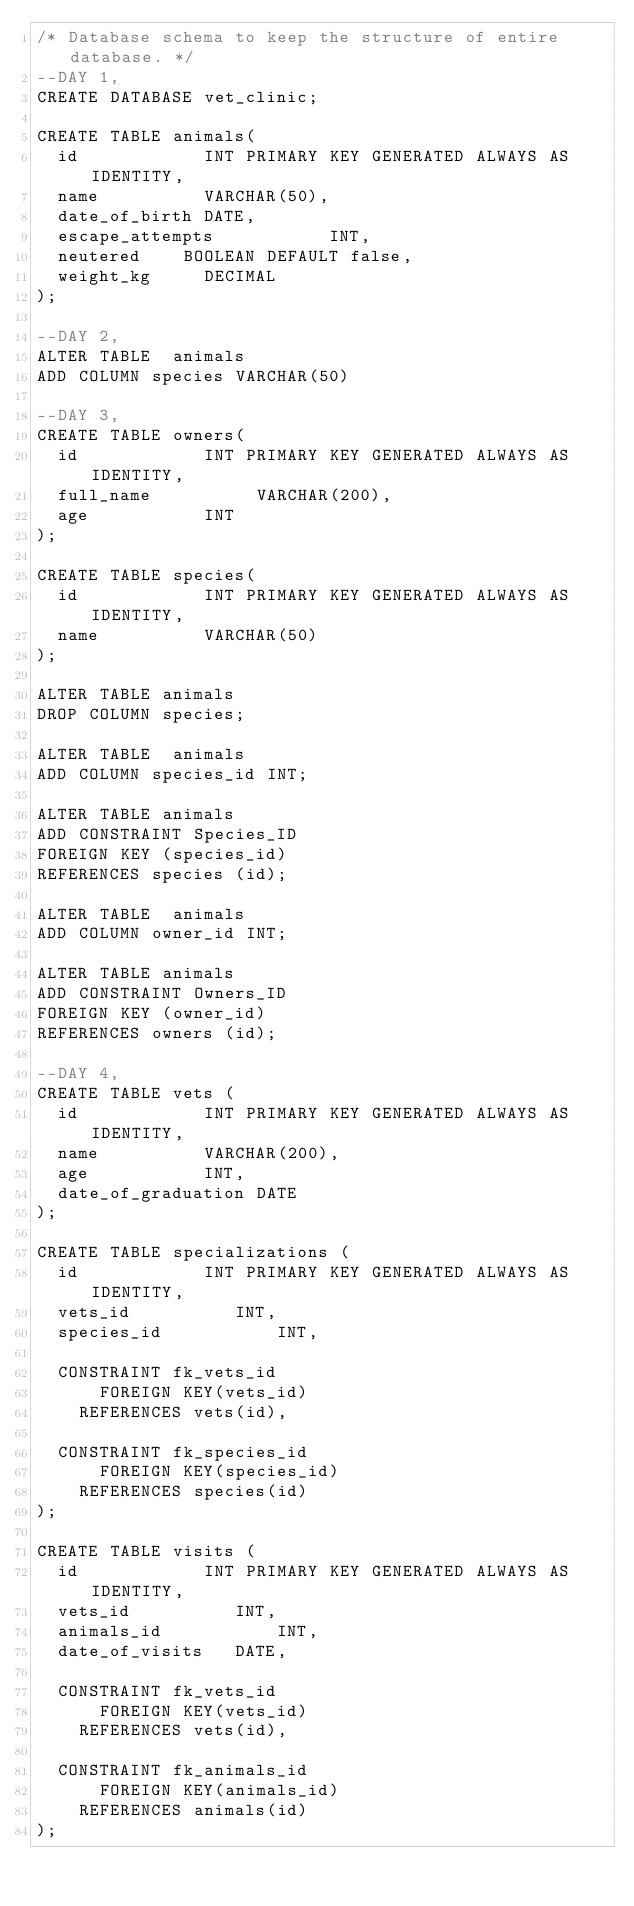<code> <loc_0><loc_0><loc_500><loc_500><_SQL_>/* Database schema to keep the structure of entire database. */
--DAY 1,
CREATE DATABASE vet_clinic;

CREATE TABLE animals(
  id            INT PRIMARY KEY GENERATED ALWAYS AS IDENTITY,
  name          VARCHAR(50),
  date_of_birth DATE,
  escape_attempts           INT,
  neutered    BOOLEAN DEFAULT false,
  weight_kg     DECIMAL
);

--DAY 2,
ALTER TABLE  animals 
ADD COLUMN species VARCHAR(50)

--DAY 3,
CREATE TABLE owners(
  id            INT PRIMARY KEY GENERATED ALWAYS AS IDENTITY,
  full_name          VARCHAR(200),
  age           INT
);

CREATE TABLE species(
  id            INT PRIMARY KEY GENERATED ALWAYS AS IDENTITY,
  name          VARCHAR(50)
);

ALTER TABLE animals
DROP COLUMN species;

ALTER TABLE  animals 
ADD COLUMN species_id INT;

ALTER TABLE animals
ADD CONSTRAINT Species_ID 
FOREIGN KEY (species_id) 
REFERENCES species (id);

ALTER TABLE  animals 
ADD COLUMN owner_id INT;

ALTER TABLE animals
ADD CONSTRAINT Owners_ID 
FOREIGN KEY (owner_id) 
REFERENCES owners (id);

--DAY 4,
CREATE TABLE vets (
  id            INT PRIMARY KEY GENERATED ALWAYS AS IDENTITY,
  name          VARCHAR(200),
  age           INT,
  date_of_graduation DATE
);

CREATE TABLE specializations (
  id            INT PRIMARY KEY GENERATED ALWAYS AS IDENTITY,
  vets_id          INT,
  species_id           INT,

  CONSTRAINT fk_vets_id
      FOREIGN KEY(vets_id) 
	  REFERENCES vets(id),

  CONSTRAINT fk_species_id
      FOREIGN KEY(species_id) 
	  REFERENCES species(id)      
);

CREATE TABLE visits (
  id            INT PRIMARY KEY GENERATED ALWAYS AS IDENTITY,
  vets_id          INT,
  animals_id           INT,
  date_of_visits   DATE,

  CONSTRAINT fk_vets_id
      FOREIGN KEY(vets_id) 
	  REFERENCES vets(id),

  CONSTRAINT fk_animals_id
      FOREIGN KEY(animals_id) 
	  REFERENCES animals(id)      
);
</code> 